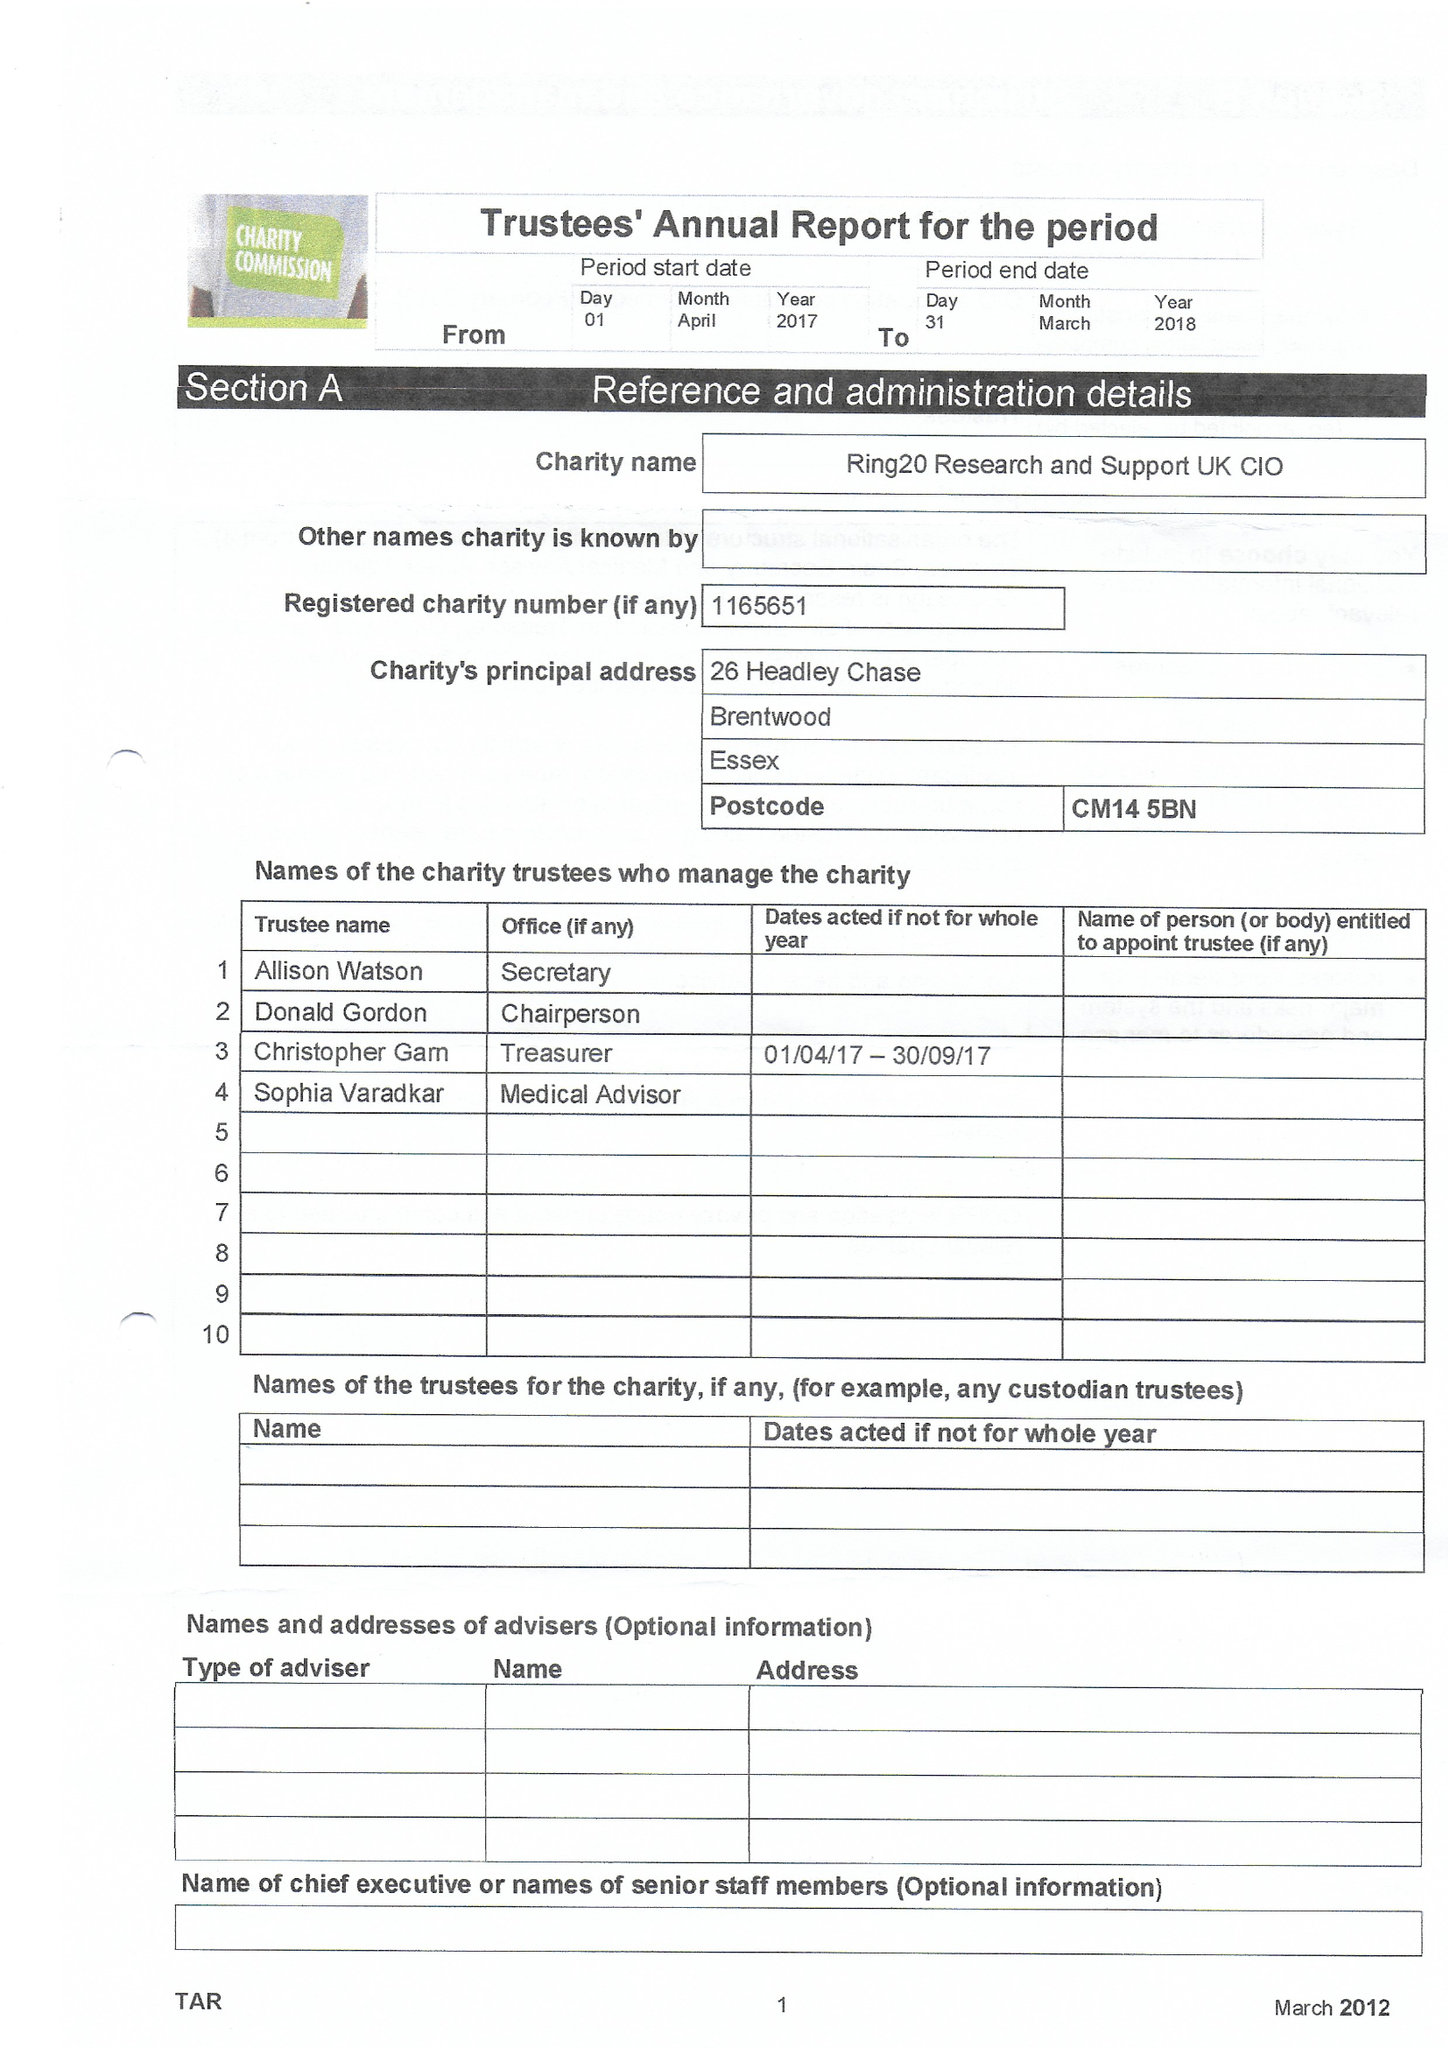What is the value for the address__post_town?
Answer the question using a single word or phrase. BRENTWOOD 